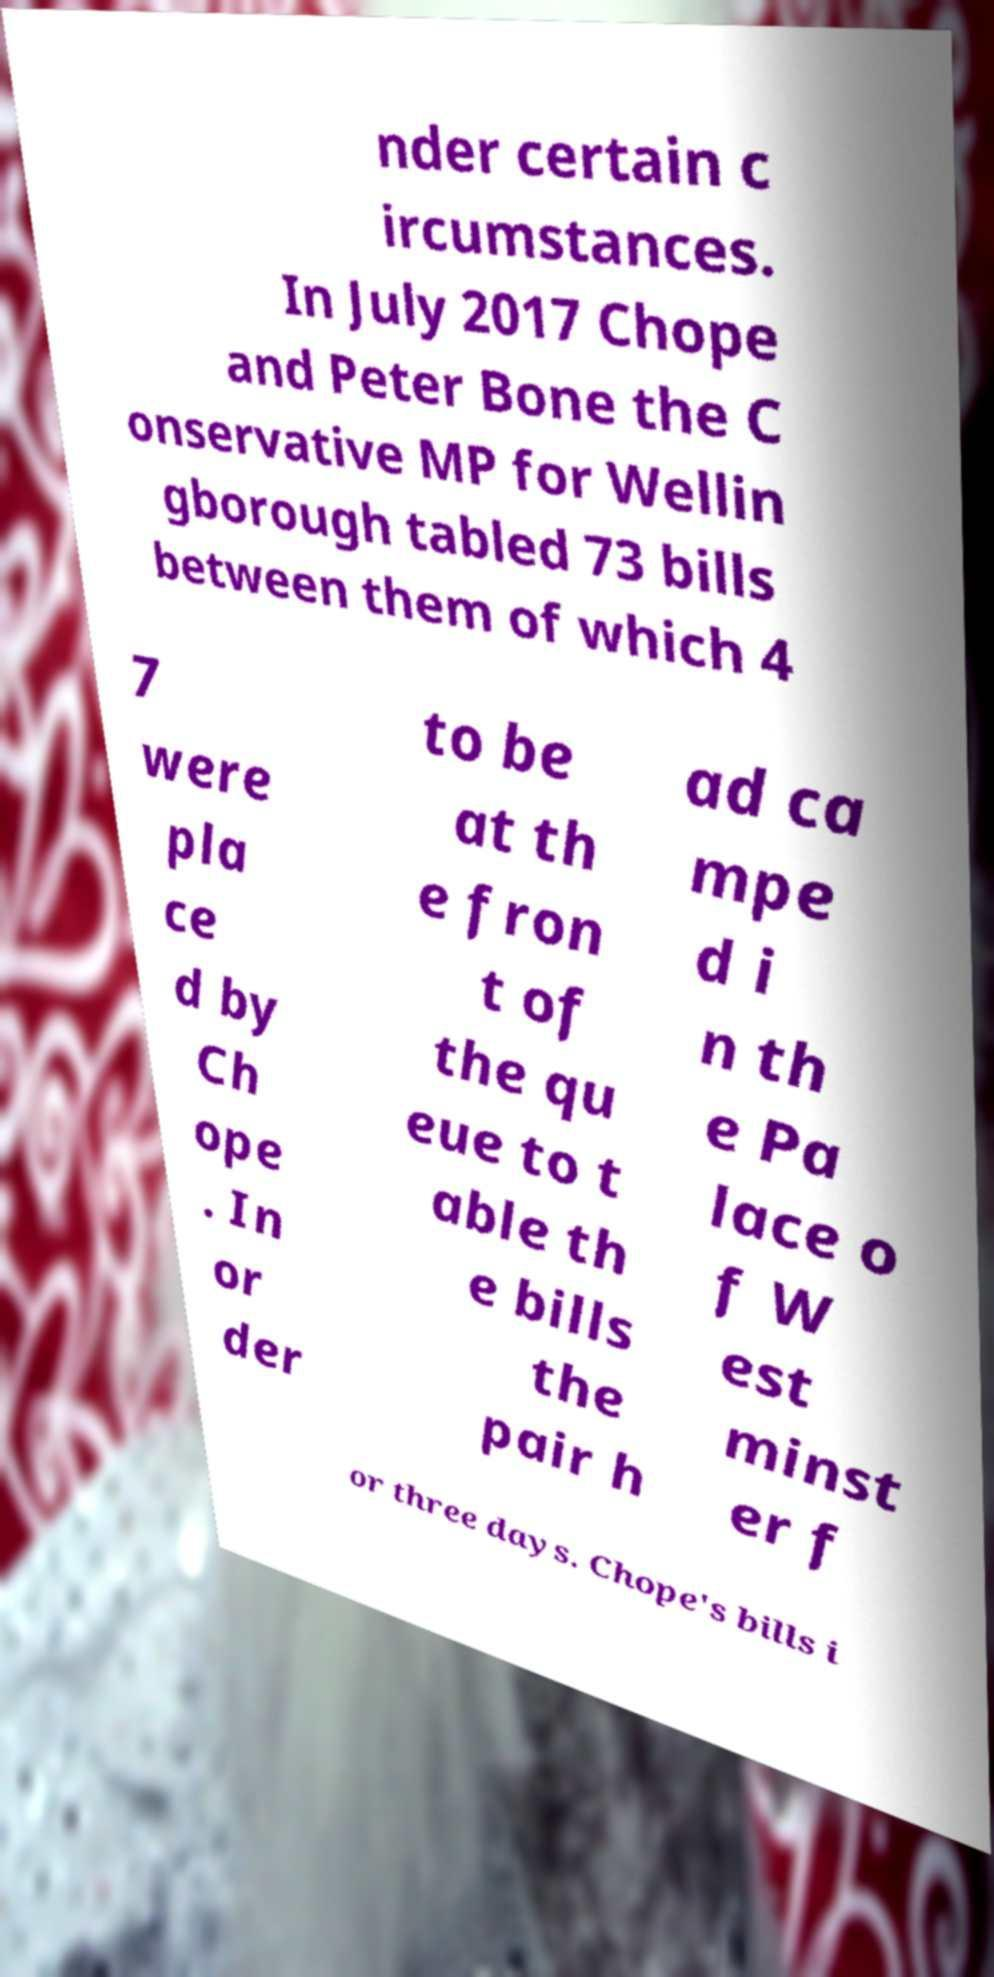Please identify and transcribe the text found in this image. nder certain c ircumstances. In July 2017 Chope and Peter Bone the C onservative MP for Wellin gborough tabled 73 bills between them of which 4 7 were pla ce d by Ch ope . In or der to be at th e fron t of the qu eue to t able th e bills the pair h ad ca mpe d i n th e Pa lace o f W est minst er f or three days. Chope's bills i 